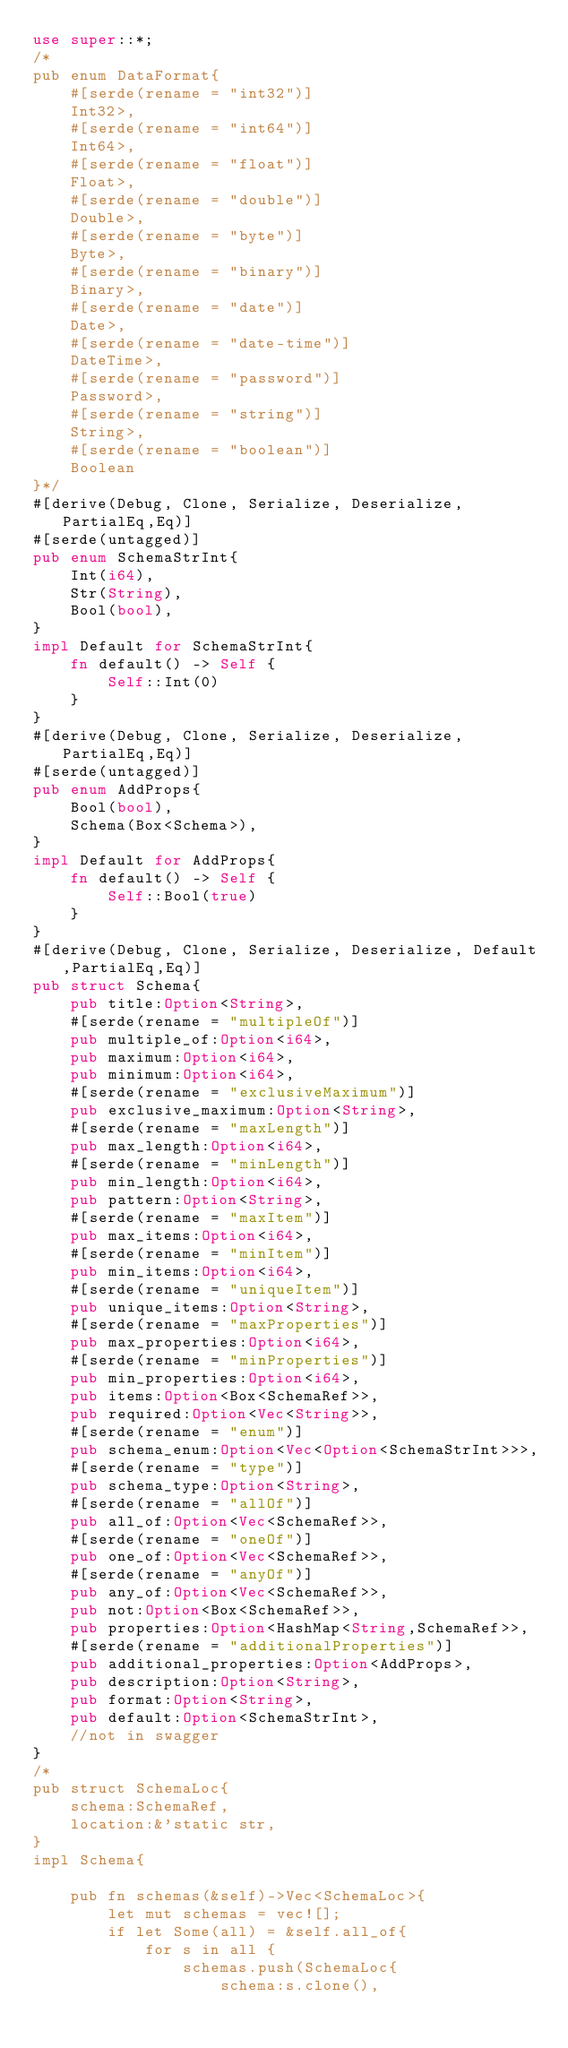Convert code to text. <code><loc_0><loc_0><loc_500><loc_500><_Rust_>use super::*;
/*
pub enum DataFormat{
    #[serde(rename = "int32")]
    Int32>,
    #[serde(rename = "int64")]
    Int64>,
    #[serde(rename = "float")]
    Float>,
    #[serde(rename = "double")]
    Double>,
    #[serde(rename = "byte")]
    Byte>,
    #[serde(rename = "binary")]
    Binary>,
    #[serde(rename = "date")]
    Date>,
    #[serde(rename = "date-time")]
    DateTime>,
    #[serde(rename = "password")]
    Password>,
    #[serde(rename = "string")]
    String>,
    #[serde(rename = "boolean")]
    Boolean
}*/
#[derive(Debug, Clone, Serialize, Deserialize,PartialEq,Eq)]
#[serde(untagged)]
pub enum SchemaStrInt{
    Int(i64),
    Str(String),
    Bool(bool),
}
impl Default for SchemaStrInt{
    fn default() -> Self {
        Self::Int(0)
    }
}
#[derive(Debug, Clone, Serialize, Deserialize,PartialEq,Eq)]
#[serde(untagged)]
pub enum AddProps{
    Bool(bool),
    Schema(Box<Schema>),
}
impl Default for AddProps{
    fn default() -> Self {
        Self::Bool(true)
    }
}
#[derive(Debug, Clone, Serialize, Deserialize, Default,PartialEq,Eq)]
pub struct Schema{
    pub title:Option<String>,
    #[serde(rename = "multipleOf")]
    pub multiple_of:Option<i64>,
    pub maximum:Option<i64>,
    pub minimum:Option<i64>,
    #[serde(rename = "exclusiveMaximum")]
    pub exclusive_maximum:Option<String>,
    #[serde(rename = "maxLength")]
    pub max_length:Option<i64>,
    #[serde(rename = "minLength")]
    pub min_length:Option<i64>,
    pub pattern:Option<String>,
    #[serde(rename = "maxItem")]
    pub max_items:Option<i64>,
    #[serde(rename = "minItem")]
    pub min_items:Option<i64>,
    #[serde(rename = "uniqueItem")]
    pub unique_items:Option<String>,
    #[serde(rename = "maxProperties")]
    pub max_properties:Option<i64>,
    #[serde(rename = "minProperties")]
    pub min_properties:Option<i64>,
    pub items:Option<Box<SchemaRef>>,
    pub required:Option<Vec<String>>,
    #[serde(rename = "enum")]
    pub schema_enum:Option<Vec<Option<SchemaStrInt>>>,
    #[serde(rename = "type")]
    pub schema_type:Option<String>,
    #[serde(rename = "allOf")]
    pub all_of:Option<Vec<SchemaRef>>,
    #[serde(rename = "oneOf")]
    pub one_of:Option<Vec<SchemaRef>>,
    #[serde(rename = "anyOf")]
    pub any_of:Option<Vec<SchemaRef>>,
    pub not:Option<Box<SchemaRef>>,
    pub properties:Option<HashMap<String,SchemaRef>>,
    #[serde(rename = "additionalProperties")]
    pub additional_properties:Option<AddProps>,
    pub description:Option<String>,
    pub format:Option<String>,
    pub default:Option<SchemaStrInt>,
    //not in swagger
}
/*
pub struct SchemaLoc{
    schema:SchemaRef,
    location:&'static str,
}
impl Schema{
    
    pub fn schemas(&self)->Vec<SchemaLoc>{
        let mut schemas = vec![];
        if let Some(all) = &self.all_of{
            for s in all {
                schemas.push(SchemaLoc{
                    schema:s.clone(),</code> 